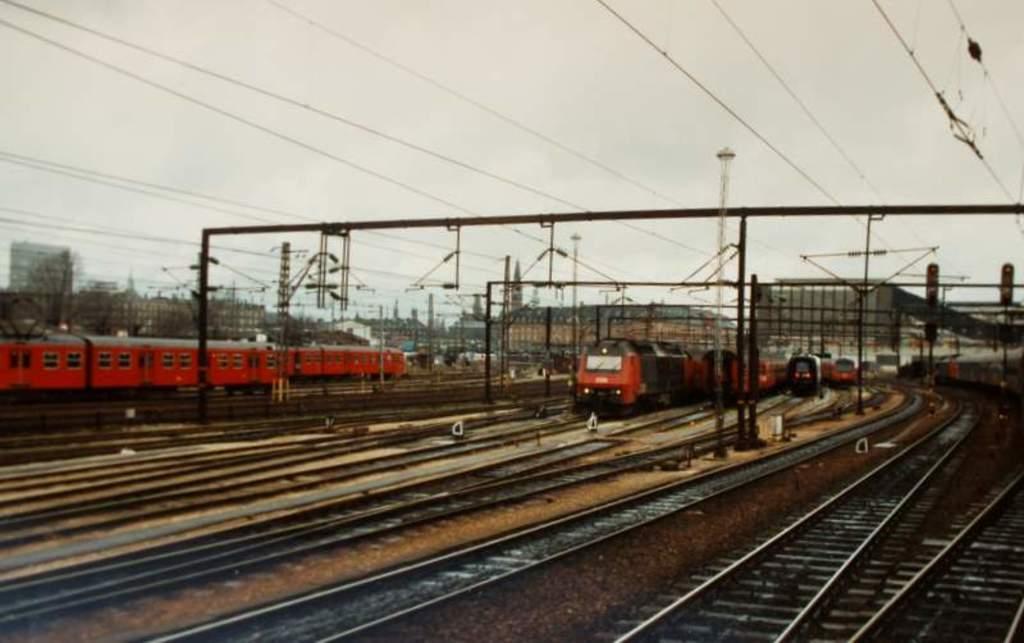In one or two sentences, can you explain what this image depicts? In this image, we can see some tracks, trains and metal frames. In the background of the image, we can see wires and sky. 